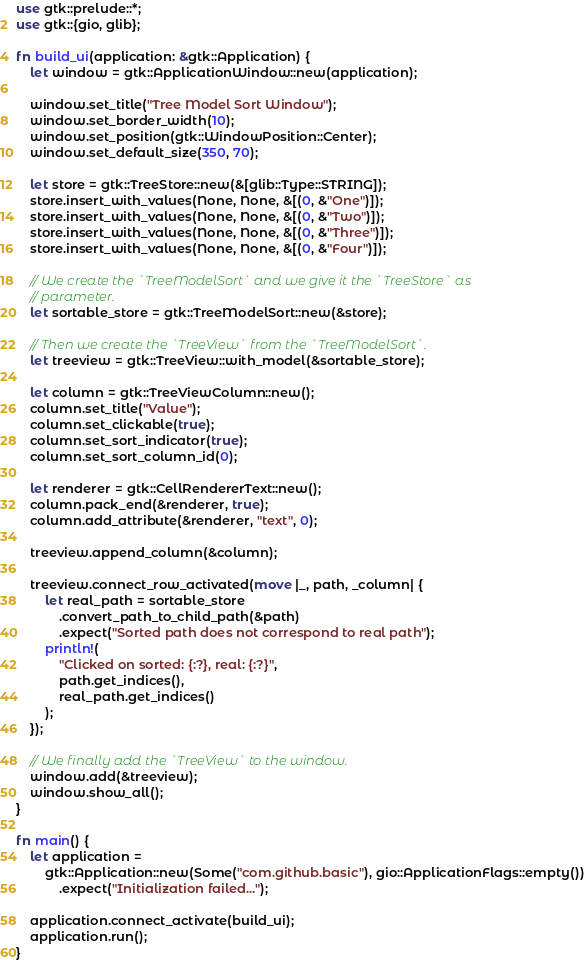<code> <loc_0><loc_0><loc_500><loc_500><_Rust_>use gtk::prelude::*;
use gtk::{gio, glib};

fn build_ui(application: &gtk::Application) {
    let window = gtk::ApplicationWindow::new(application);

    window.set_title("Tree Model Sort Window");
    window.set_border_width(10);
    window.set_position(gtk::WindowPosition::Center);
    window.set_default_size(350, 70);

    let store = gtk::TreeStore::new(&[glib::Type::STRING]);
    store.insert_with_values(None, None, &[(0, &"One")]);
    store.insert_with_values(None, None, &[(0, &"Two")]);
    store.insert_with_values(None, None, &[(0, &"Three")]);
    store.insert_with_values(None, None, &[(0, &"Four")]);

    // We create the `TreeModelSort` and we give it the `TreeStore` as
    // parameter.
    let sortable_store = gtk::TreeModelSort::new(&store);

    // Then we create the `TreeView` from the `TreeModelSort`.
    let treeview = gtk::TreeView::with_model(&sortable_store);

    let column = gtk::TreeViewColumn::new();
    column.set_title("Value");
    column.set_clickable(true);
    column.set_sort_indicator(true);
    column.set_sort_column_id(0);

    let renderer = gtk::CellRendererText::new();
    column.pack_end(&renderer, true);
    column.add_attribute(&renderer, "text", 0);

    treeview.append_column(&column);

    treeview.connect_row_activated(move |_, path, _column| {
        let real_path = sortable_store
            .convert_path_to_child_path(&path)
            .expect("Sorted path does not correspond to real path");
        println!(
            "Clicked on sorted: {:?}, real: {:?}",
            path.get_indices(),
            real_path.get_indices()
        );
    });

    // We finally add the `TreeView` to the window.
    window.add(&treeview);
    window.show_all();
}

fn main() {
    let application =
        gtk::Application::new(Some("com.github.basic"), gio::ApplicationFlags::empty())
            .expect("Initialization failed...");

    application.connect_activate(build_ui);
    application.run();
}
</code> 